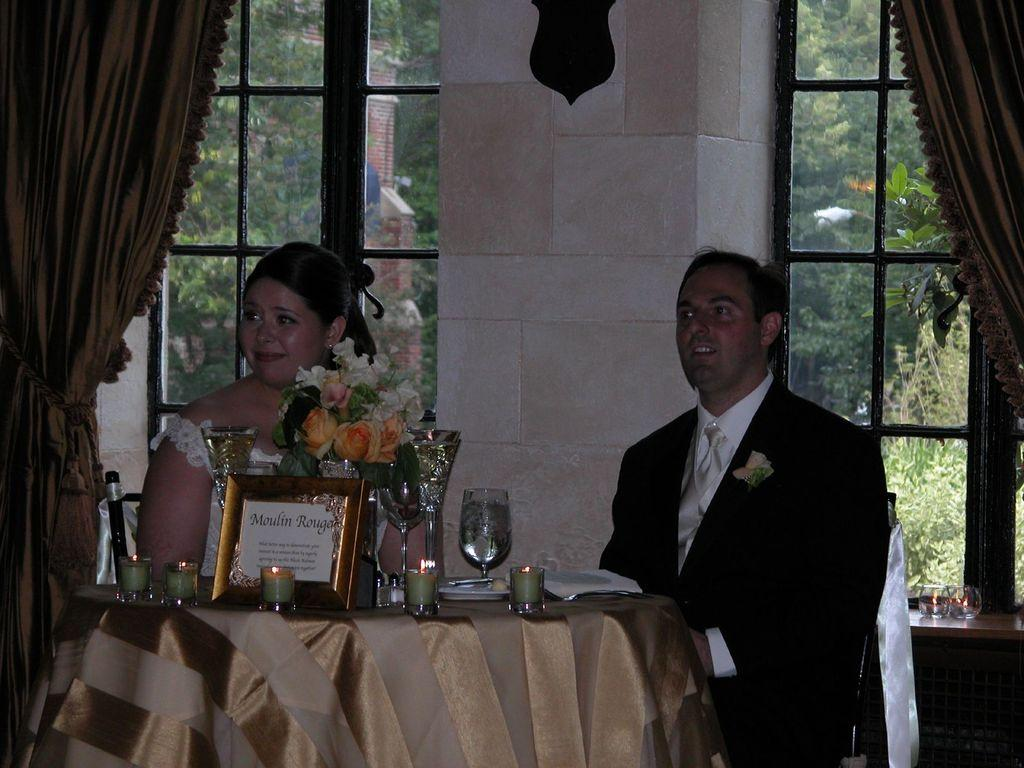How many people are present in the image? There are two people, a woman and a man, present in the image. What are the woman and the man doing in the image? Both the woman and the man are sitting on chairs. What can be seen on the table in the image? There are candles, flowers, and glasses on the table. What is visible through the window in the image? Trees are visible through the window. Is there any window treatment present in the image? Yes, there is a curtain associated with the window. Can you tell me how many squirrels are sitting on the woman's lap in the image? There are no squirrels present in the image; it features a woman and a man sitting on chairs with a table nearby. What color is the daughter's dress in the image? There is no daughter present in the image; it features a woman and a man. 